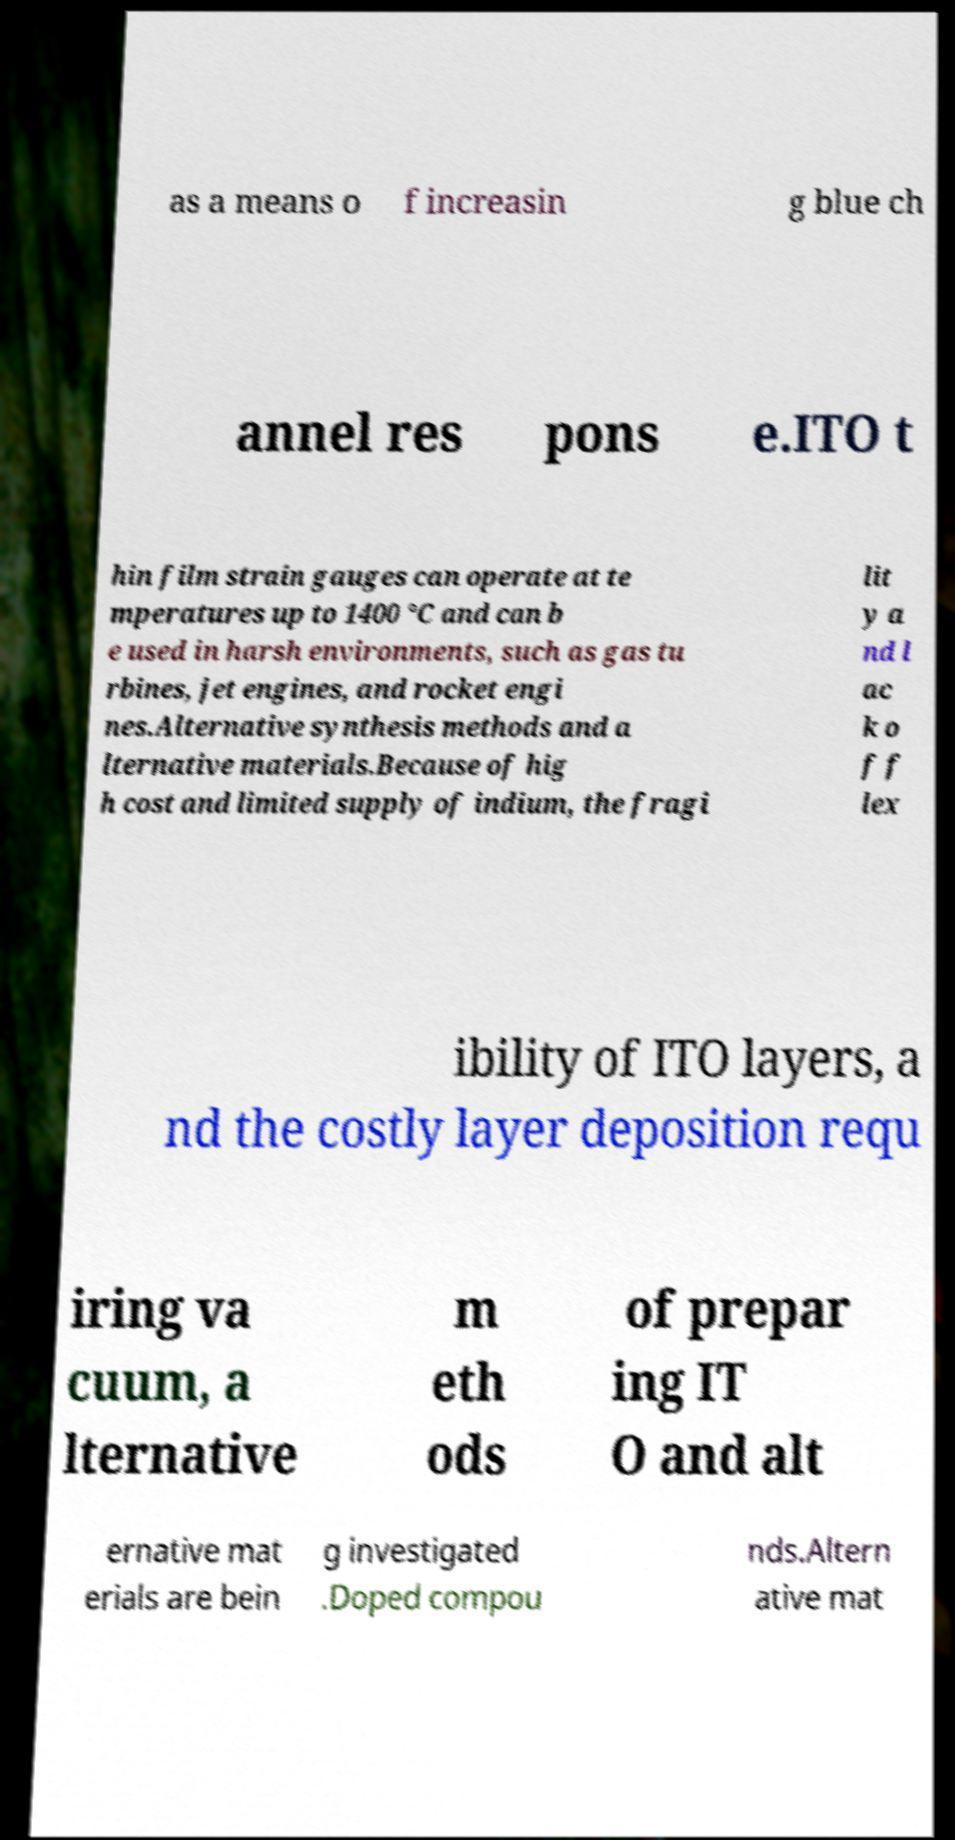There's text embedded in this image that I need extracted. Can you transcribe it verbatim? as a means o f increasin g blue ch annel res pons e.ITO t hin film strain gauges can operate at te mperatures up to 1400 °C and can b e used in harsh environments, such as gas tu rbines, jet engines, and rocket engi nes.Alternative synthesis methods and a lternative materials.Because of hig h cost and limited supply of indium, the fragi lit y a nd l ac k o f f lex ibility of ITO layers, a nd the costly layer deposition requ iring va cuum, a lternative m eth ods of prepar ing IT O and alt ernative mat erials are bein g investigated .Doped compou nds.Altern ative mat 